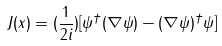Convert formula to latex. <formula><loc_0><loc_0><loc_500><loc_500>J ( x ) = ( \frac { 1 } { 2 i } ) [ \psi ^ { \dagger } ( \nabla \psi ) - ( \nabla \psi ) ^ { \dagger } \psi ]</formula> 